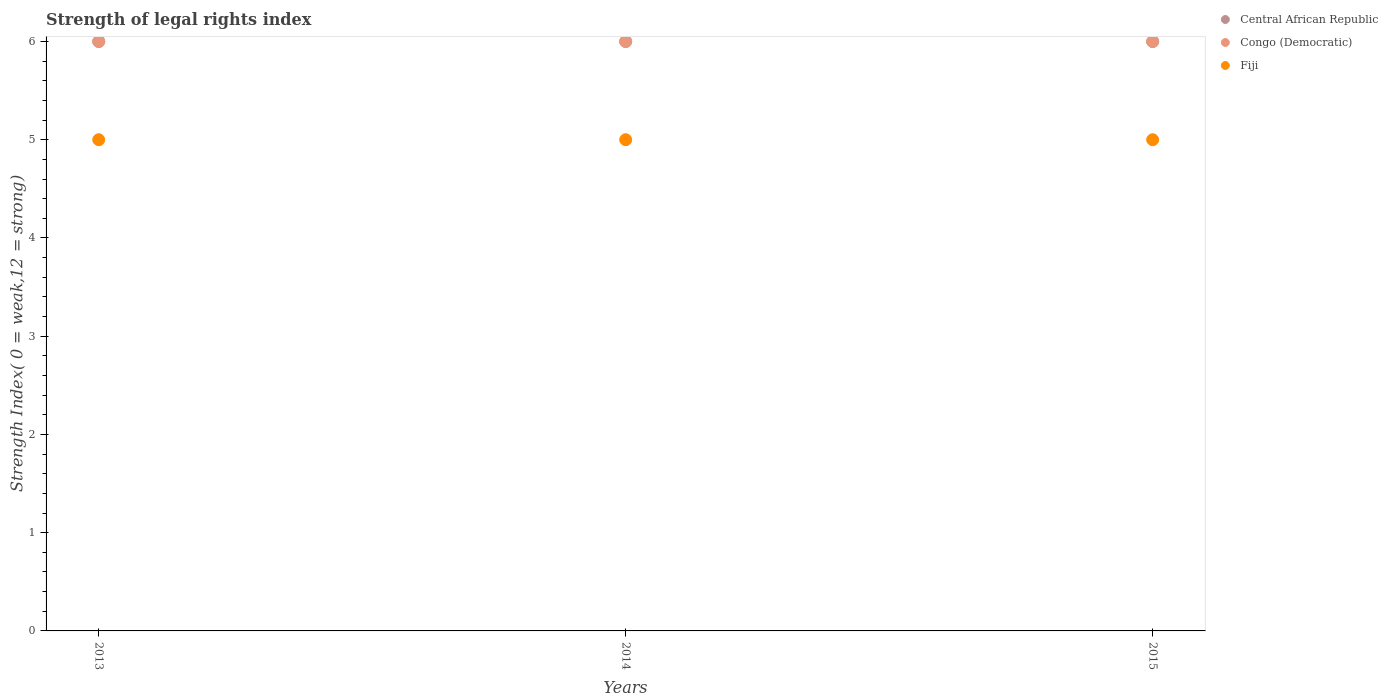Across all years, what is the maximum strength index in Fiji?
Provide a short and direct response. 5. Across all years, what is the minimum strength index in Congo (Democratic)?
Ensure brevity in your answer.  6. In which year was the strength index in Congo (Democratic) maximum?
Ensure brevity in your answer.  2013. In which year was the strength index in Fiji minimum?
Make the answer very short. 2013. What is the total strength index in Congo (Democratic) in the graph?
Provide a succinct answer. 18. What is the difference between the strength index in Central African Republic in 2013 and that in 2014?
Your response must be concise. 0. What is the difference between the strength index in Central African Republic in 2013 and the strength index in Fiji in 2014?
Provide a short and direct response. 1. What is the average strength index in Congo (Democratic) per year?
Keep it short and to the point. 6. In the year 2013, what is the difference between the strength index in Congo (Democratic) and strength index in Central African Republic?
Your answer should be very brief. 0. Is the difference between the strength index in Congo (Democratic) in 2013 and 2014 greater than the difference between the strength index in Central African Republic in 2013 and 2014?
Give a very brief answer. No. What is the difference between the highest and the second highest strength index in Congo (Democratic)?
Your answer should be compact. 0. Is the sum of the strength index in Central African Republic in 2013 and 2015 greater than the maximum strength index in Congo (Democratic) across all years?
Offer a very short reply. Yes. Is it the case that in every year, the sum of the strength index in Congo (Democratic) and strength index in Fiji  is greater than the strength index in Central African Republic?
Your response must be concise. Yes. Does the strength index in Central African Republic monotonically increase over the years?
Your answer should be compact. No. Are the values on the major ticks of Y-axis written in scientific E-notation?
Offer a terse response. No. How many legend labels are there?
Provide a succinct answer. 3. What is the title of the graph?
Your answer should be compact. Strength of legal rights index. What is the label or title of the Y-axis?
Offer a very short reply. Strength Index( 0 = weak,12 = strong). What is the Strength Index( 0 = weak,12 = strong) of Central African Republic in 2013?
Provide a short and direct response. 6. What is the Strength Index( 0 = weak,12 = strong) of Congo (Democratic) in 2013?
Offer a very short reply. 6. What is the Strength Index( 0 = weak,12 = strong) of Fiji in 2013?
Offer a very short reply. 5. What is the Strength Index( 0 = weak,12 = strong) in Central African Republic in 2014?
Your answer should be compact. 6. What is the Strength Index( 0 = weak,12 = strong) in Congo (Democratic) in 2015?
Give a very brief answer. 6. Across all years, what is the maximum Strength Index( 0 = weak,12 = strong) in Congo (Democratic)?
Keep it short and to the point. 6. Across all years, what is the minimum Strength Index( 0 = weak,12 = strong) of Central African Republic?
Keep it short and to the point. 6. Across all years, what is the minimum Strength Index( 0 = weak,12 = strong) of Congo (Democratic)?
Offer a terse response. 6. What is the total Strength Index( 0 = weak,12 = strong) in Fiji in the graph?
Offer a very short reply. 15. What is the difference between the Strength Index( 0 = weak,12 = strong) of Central African Republic in 2013 and that in 2014?
Provide a succinct answer. 0. What is the difference between the Strength Index( 0 = weak,12 = strong) of Congo (Democratic) in 2013 and that in 2014?
Offer a very short reply. 0. What is the difference between the Strength Index( 0 = weak,12 = strong) in Central African Republic in 2013 and that in 2015?
Offer a very short reply. 0. What is the difference between the Strength Index( 0 = weak,12 = strong) of Congo (Democratic) in 2013 and that in 2015?
Give a very brief answer. 0. What is the difference between the Strength Index( 0 = weak,12 = strong) of Congo (Democratic) in 2014 and that in 2015?
Ensure brevity in your answer.  0. What is the difference between the Strength Index( 0 = weak,12 = strong) in Central African Republic in 2013 and the Strength Index( 0 = weak,12 = strong) in Congo (Democratic) in 2014?
Offer a terse response. 0. What is the difference between the Strength Index( 0 = weak,12 = strong) in Central African Republic in 2013 and the Strength Index( 0 = weak,12 = strong) in Fiji in 2014?
Offer a very short reply. 1. What is the difference between the Strength Index( 0 = weak,12 = strong) in Congo (Democratic) in 2013 and the Strength Index( 0 = weak,12 = strong) in Fiji in 2014?
Ensure brevity in your answer.  1. What is the difference between the Strength Index( 0 = weak,12 = strong) in Central African Republic in 2013 and the Strength Index( 0 = weak,12 = strong) in Fiji in 2015?
Ensure brevity in your answer.  1. What is the difference between the Strength Index( 0 = weak,12 = strong) in Congo (Democratic) in 2013 and the Strength Index( 0 = weak,12 = strong) in Fiji in 2015?
Provide a short and direct response. 1. What is the difference between the Strength Index( 0 = weak,12 = strong) in Central African Republic in 2014 and the Strength Index( 0 = weak,12 = strong) in Congo (Democratic) in 2015?
Give a very brief answer. 0. What is the difference between the Strength Index( 0 = weak,12 = strong) in Congo (Democratic) in 2014 and the Strength Index( 0 = weak,12 = strong) in Fiji in 2015?
Provide a succinct answer. 1. What is the average Strength Index( 0 = weak,12 = strong) in Central African Republic per year?
Ensure brevity in your answer.  6. In the year 2013, what is the difference between the Strength Index( 0 = weak,12 = strong) in Central African Republic and Strength Index( 0 = weak,12 = strong) in Fiji?
Your answer should be compact. 1. In the year 2014, what is the difference between the Strength Index( 0 = weak,12 = strong) of Central African Republic and Strength Index( 0 = weak,12 = strong) of Congo (Democratic)?
Your response must be concise. 0. What is the ratio of the Strength Index( 0 = weak,12 = strong) in Fiji in 2013 to that in 2014?
Provide a short and direct response. 1. What is the ratio of the Strength Index( 0 = weak,12 = strong) of Central African Republic in 2013 to that in 2015?
Give a very brief answer. 1. What is the ratio of the Strength Index( 0 = weak,12 = strong) of Central African Republic in 2014 to that in 2015?
Your answer should be very brief. 1. What is the ratio of the Strength Index( 0 = weak,12 = strong) in Fiji in 2014 to that in 2015?
Provide a succinct answer. 1. What is the difference between the highest and the second highest Strength Index( 0 = weak,12 = strong) in Central African Republic?
Provide a short and direct response. 0. What is the difference between the highest and the second highest Strength Index( 0 = weak,12 = strong) of Congo (Democratic)?
Your answer should be very brief. 0. What is the difference between the highest and the second highest Strength Index( 0 = weak,12 = strong) of Fiji?
Keep it short and to the point. 0. What is the difference between the highest and the lowest Strength Index( 0 = weak,12 = strong) in Central African Republic?
Give a very brief answer. 0. What is the difference between the highest and the lowest Strength Index( 0 = weak,12 = strong) of Congo (Democratic)?
Provide a short and direct response. 0. What is the difference between the highest and the lowest Strength Index( 0 = weak,12 = strong) in Fiji?
Offer a very short reply. 0. 